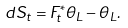Convert formula to latex. <formula><loc_0><loc_0><loc_500><loc_500>d S _ { t } = F _ { t } ^ { * } \theta _ { L } - \theta _ { L } .</formula> 